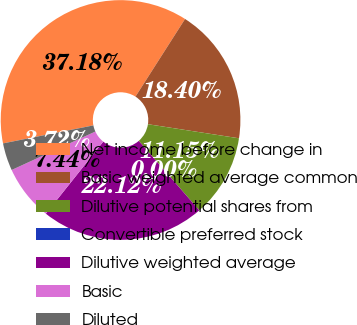<chart> <loc_0><loc_0><loc_500><loc_500><pie_chart><fcel>Net income before change in<fcel>Basic weighted average common<fcel>Dilutive potential shares from<fcel>Convertible preferred stock<fcel>Dilutive weighted average<fcel>Basic<fcel>Diluted<nl><fcel>37.18%<fcel>18.4%<fcel>11.15%<fcel>0.0%<fcel>22.12%<fcel>7.44%<fcel>3.72%<nl></chart> 